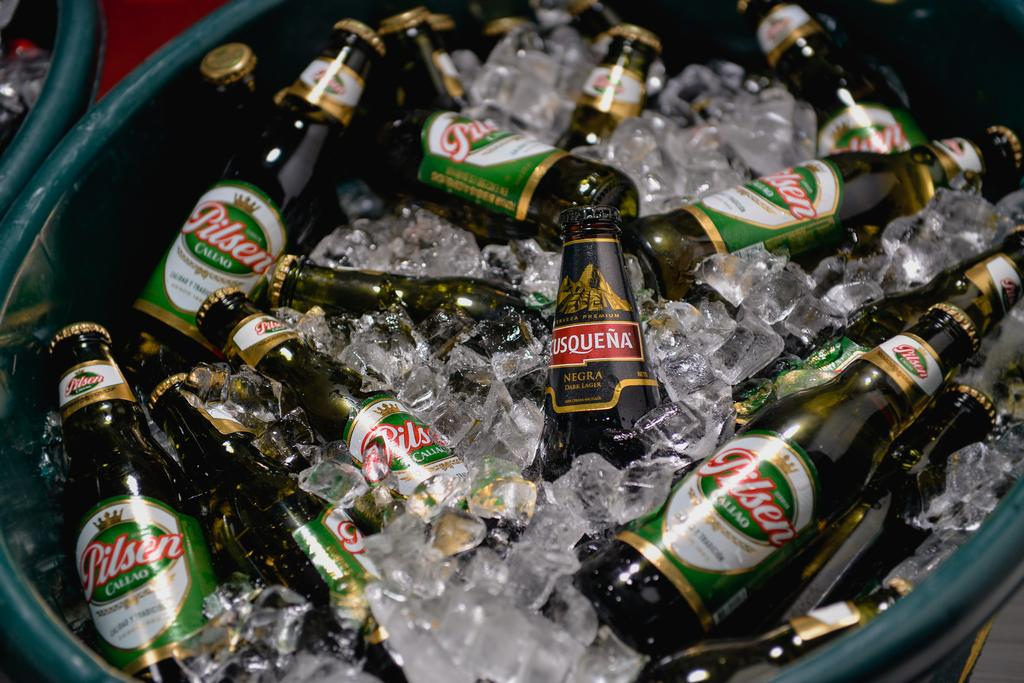Provide a one-sentence caption for the provided image. A green tub filled with bottles of Pilsen beer and ice. 